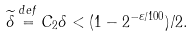<formula> <loc_0><loc_0><loc_500><loc_500>\widetilde { \delta } \stackrel { d e f } { = } C _ { 2 } \delta < ( 1 - 2 ^ { - \varepsilon / 1 0 0 } ) / 2 .</formula> 